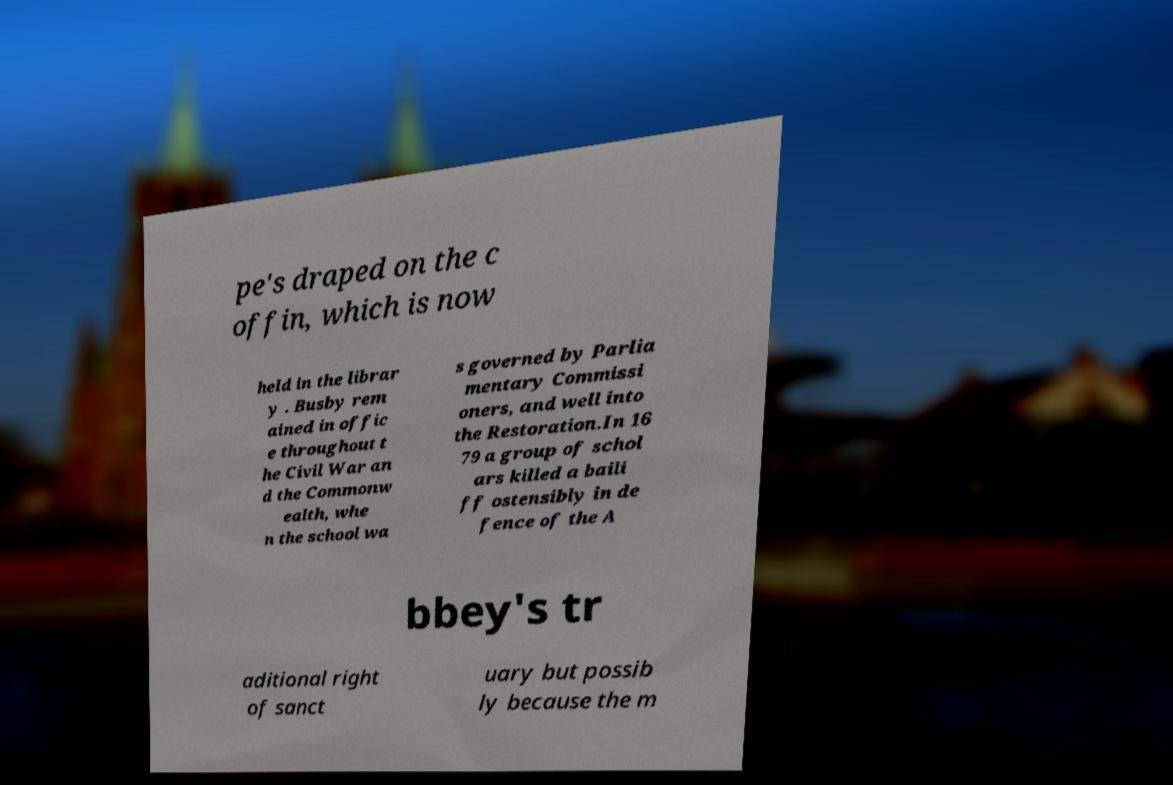What messages or text are displayed in this image? I need them in a readable, typed format. pe's draped on the c offin, which is now held in the librar y . Busby rem ained in offic e throughout t he Civil War an d the Commonw ealth, whe n the school wa s governed by Parlia mentary Commissi oners, and well into the Restoration.In 16 79 a group of schol ars killed a baili ff ostensibly in de fence of the A bbey's tr aditional right of sanct uary but possib ly because the m 